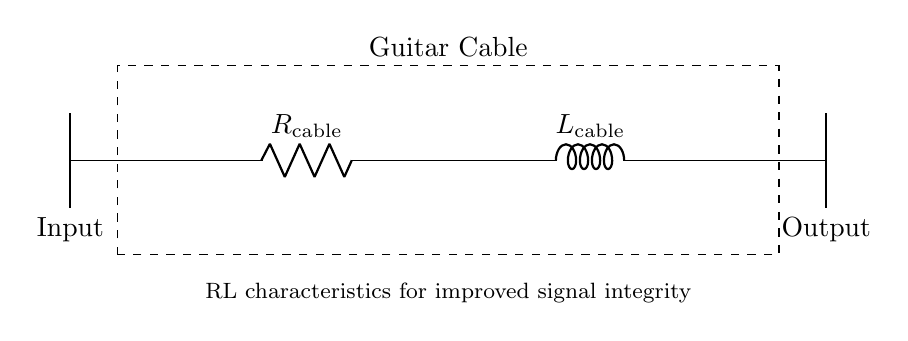What type of components are in this circuit? The circuit consists of a resistor and inductor, which are essential for creating RL characteristics. The diagram labels the resistor as R cable and the inductor as L cable.
Answer: Resistor and inductor What does R cable represent in the circuit? R cable represents the resistance characteristic in the guitar cable, which helps in reducing signal loss. It is specifically labeled in the circuit diagram.
Answer: Resistance What does L cable represent in the circuit? L cable denotes the inductance characteristic of the guitar cable, which helps in maintaining the integrity of the audio signal during transmission. It is also clearly labeled in the diagram.
Answer: Inductance How many components are there between input and output? There are two components, R cable and L cable, that are connected in series between the input and output, as indicated by the connections in the diagram.
Answer: Two What is the relationship between resistance and inductance regarding audio quality? Resistance affects the signal amplitude and quality, while inductance can introduce a phase shift and smooth the signal, which is important for maintaining audio quality. Understanding this relationship is crucial for optimizing guitar cable performance.
Answer: Signal integrity Why is it important to include RL characteristics in a guitar cable? Including RL characteristics enhances signal integrity by minimizing losses, providing clearer sound, and ensuring better tonal quality which is essential for musicians. The circuit specifically marks these characteristics, highlighting their importance.
Answer: Improved signal integrity 